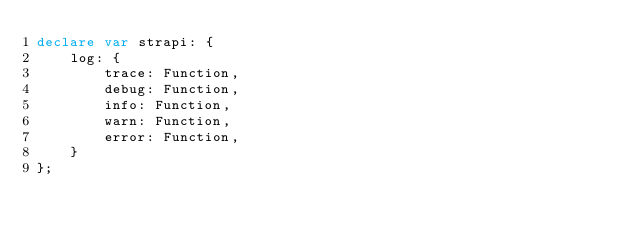<code> <loc_0><loc_0><loc_500><loc_500><_TypeScript_>declare var strapi: {
    log: {
        trace: Function,
        debug: Function,
        info: Function,
        warn: Function,
        error: Function,
    }
};
</code> 